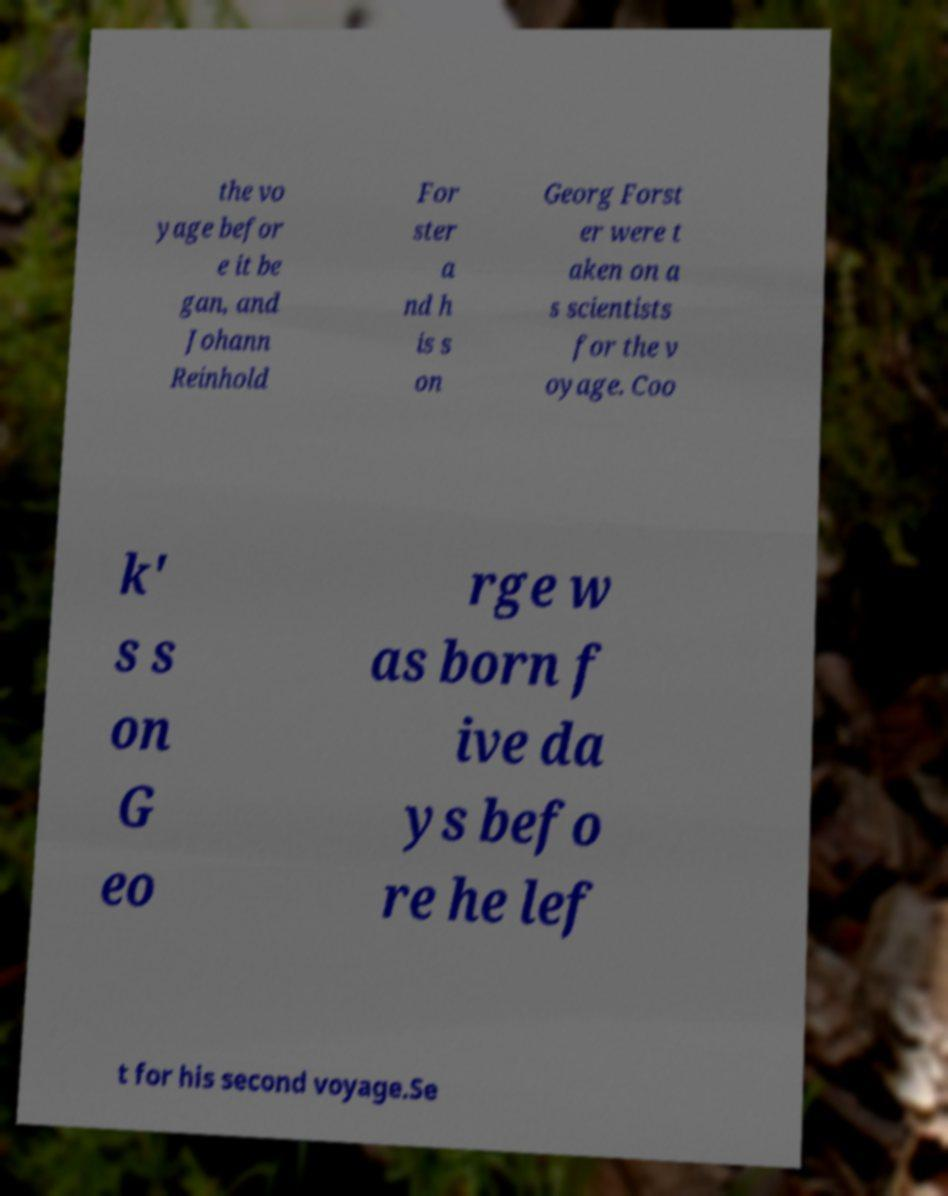Please read and relay the text visible in this image. What does it say? the vo yage befor e it be gan, and Johann Reinhold For ster a nd h is s on Georg Forst er were t aken on a s scientists for the v oyage. Coo k' s s on G eo rge w as born f ive da ys befo re he lef t for his second voyage.Se 